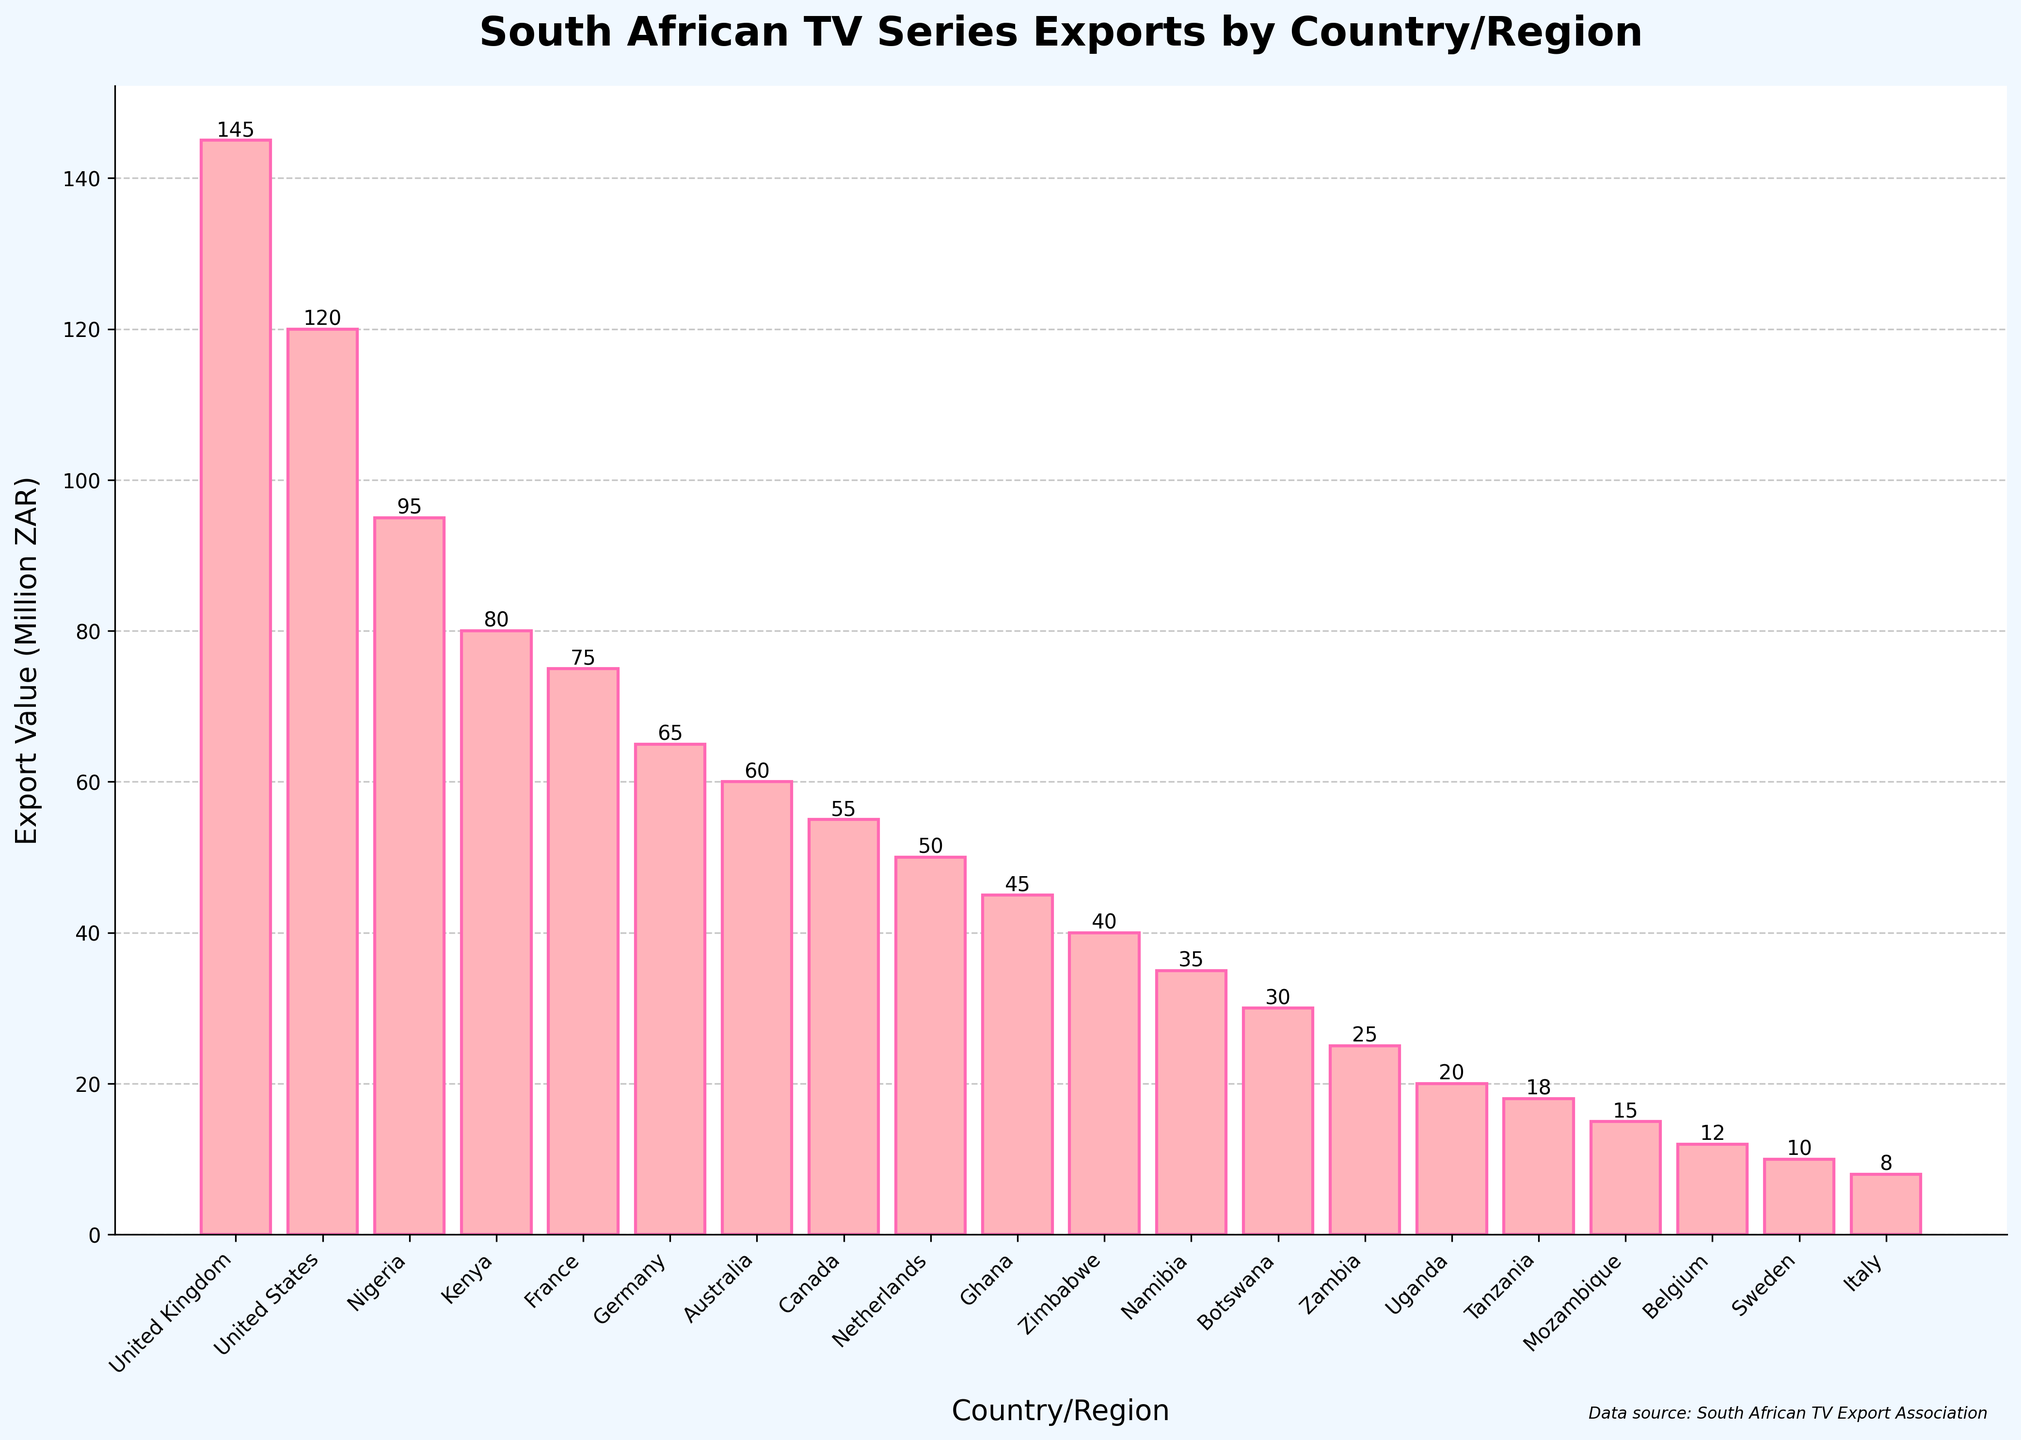What's the highest export value among the countries/regions? The highest bar indicates the United Kingdom with an export value of 145 million ZAR.
Answer: 145 million ZAR Which country/region has the lowest export value? The shortest bar represents Italy with an export value of 8 million ZAR.
Answer: Italy Is the export value to Kenya greater than that to Germany? Kenya has a bar with a height representing 80 million ZAR, while Germany's bar represents 65 million ZAR. So, Kenya's export value is indeed greater.
Answer: Yes How much more is the export value to the United States compared to that to Australia? The bar for the United States is 120 million ZAR, and the bar for Australia is 60 million ZAR. The difference is 120 - 60 = 60 million ZAR.
Answer: 60 million ZAR What’s the average export value for the top 5 countries/regions? Sum the export values for the top 5 countries/regions: (145 + 120 + 95 + 80 + 75) = 515 million ZAR, then divide by 5. So, 515 / 5 = 103 million ZAR.
Answer: 103 million ZAR Are any two countries/regions exporting the same value? By observing the heights of the bars, no two bars have the exact same height, indicating unique export values for each country/region.
Answer: No Which country/region has a 50 million ZAR export value? The bar representing 50 million ZAR corresponds to the Netherlands.
Answer: Netherlands By how much does the export value to Canada differ from that to Nigeria? Canada has an export value of 55 million ZAR, and Nigeria has 95 million ZAR. The difference is 95 - 55 = 40 million ZAR.
Answer: 40 million ZAR What’s the total export value for the African countries listed? Include Nigeria, Kenya, Ghana, Zimbabwe, Namibia, Botswana, Zambia, Uganda, Tanzania, and Mozambique. Their export values sum up to (95 + 80 + 45 + 40 + 35 + 30 + 25 + 20 + 18 + 15) = 403 million ZAR.
Answer: 403 million ZAR 